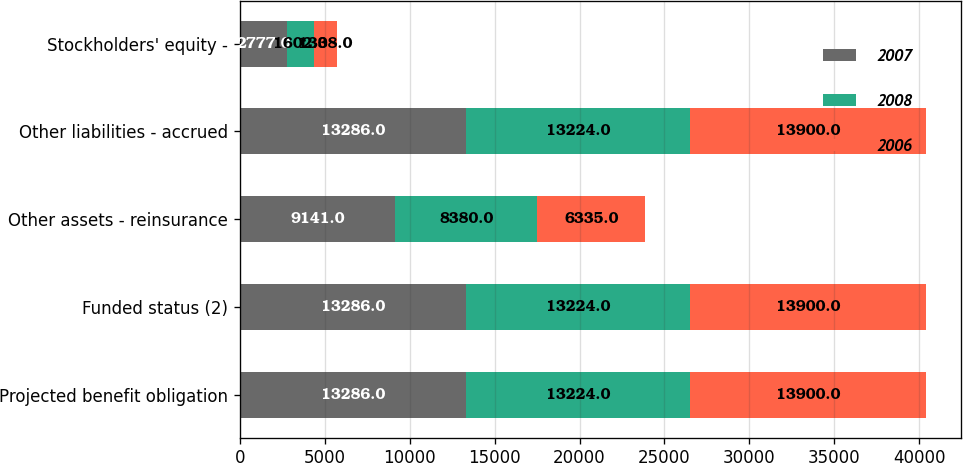<chart> <loc_0><loc_0><loc_500><loc_500><stacked_bar_chart><ecel><fcel>Projected benefit obligation<fcel>Funded status (2)<fcel>Other assets - reinsurance<fcel>Other liabilities - accrued<fcel>Stockholders' equity -<nl><fcel>2007<fcel>13286<fcel>13286<fcel>9141<fcel>13286<fcel>2777<nl><fcel>2008<fcel>13224<fcel>13224<fcel>8380<fcel>13224<fcel>1602<nl><fcel>2006<fcel>13900<fcel>13900<fcel>6335<fcel>13900<fcel>1338<nl></chart> 